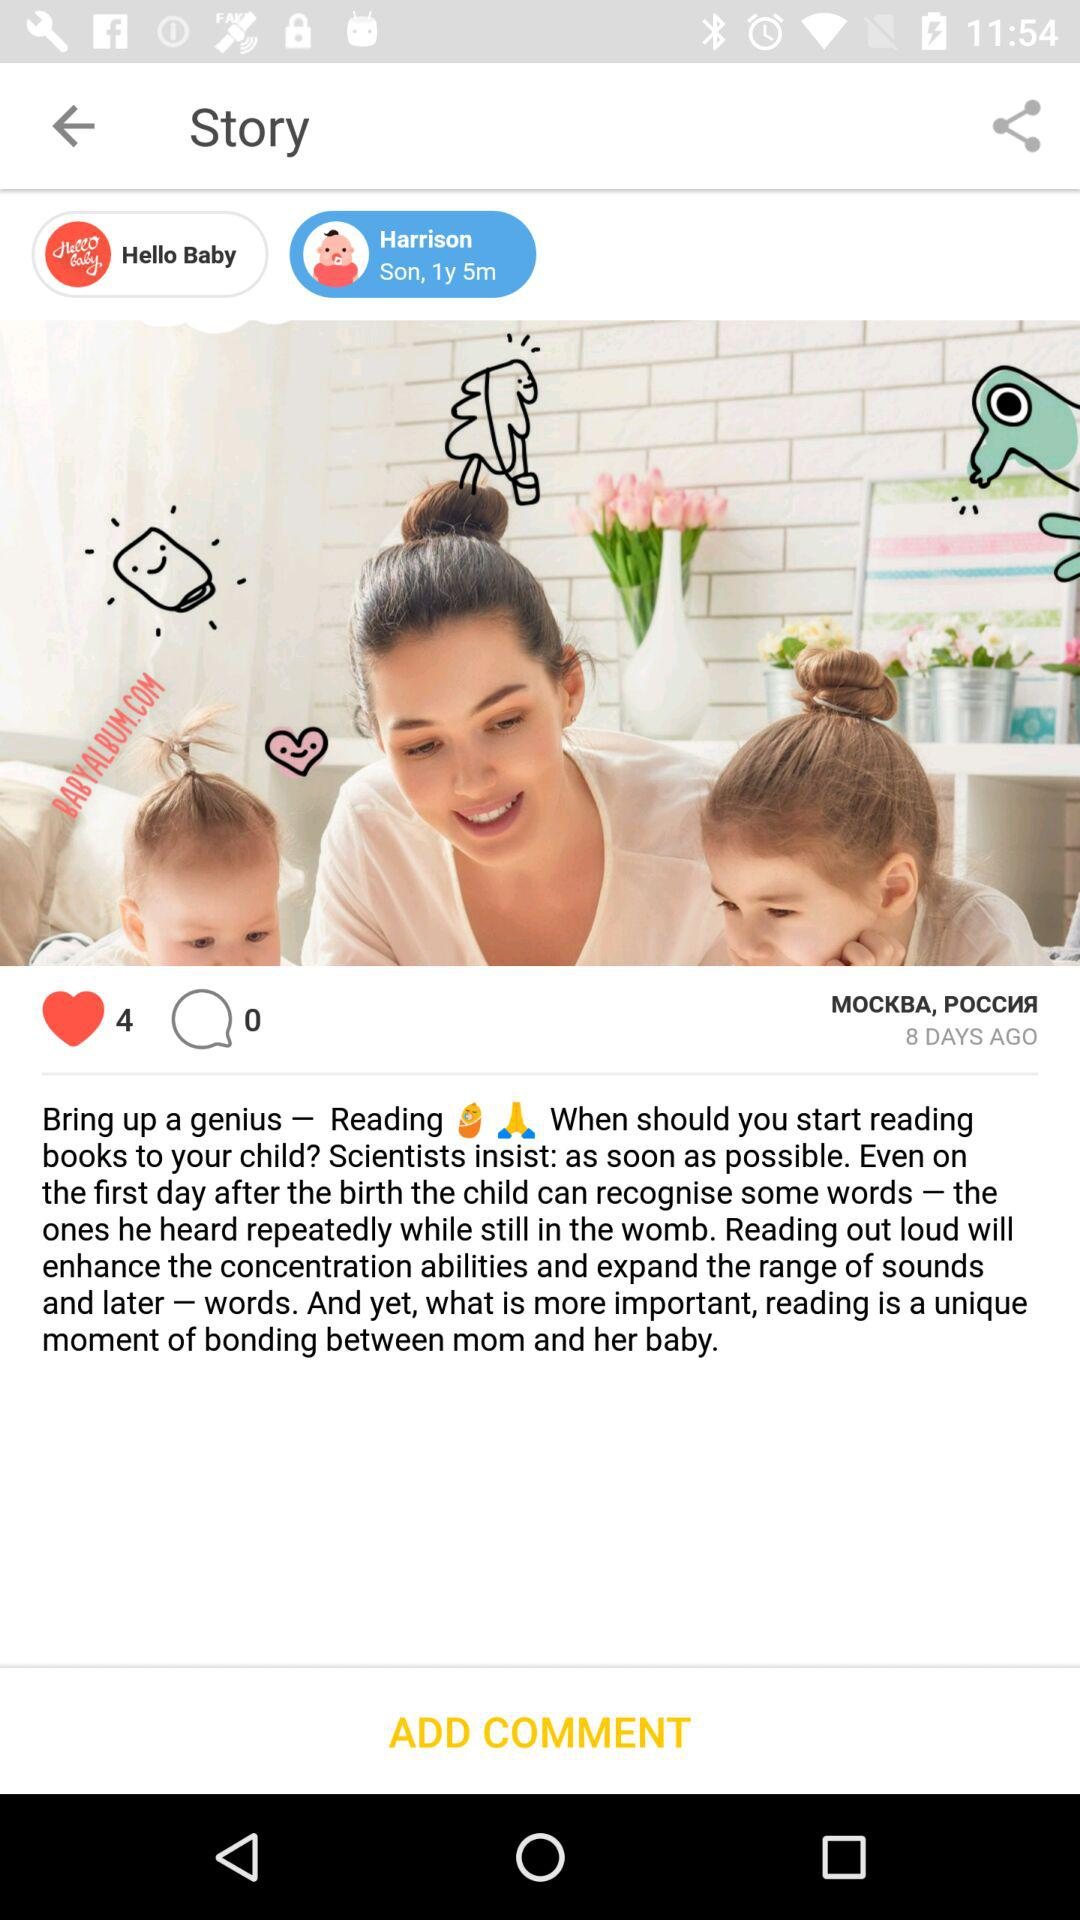How many days ago was the post posted? The post was posted 8 days ago. 